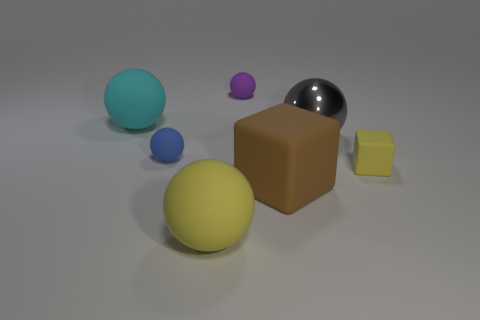Subtract all big rubber balls. How many balls are left? 3 Add 2 large metal balls. How many objects exist? 9 Subtract all brown cubes. How many cubes are left? 1 Subtract all cubes. How many objects are left? 5 Add 6 large brown cubes. How many large brown cubes are left? 7 Add 6 large matte cubes. How many large matte cubes exist? 7 Subtract 1 purple spheres. How many objects are left? 6 Subtract all red spheres. Subtract all purple blocks. How many spheres are left? 5 Subtract all tiny purple cylinders. Subtract all small blue things. How many objects are left? 6 